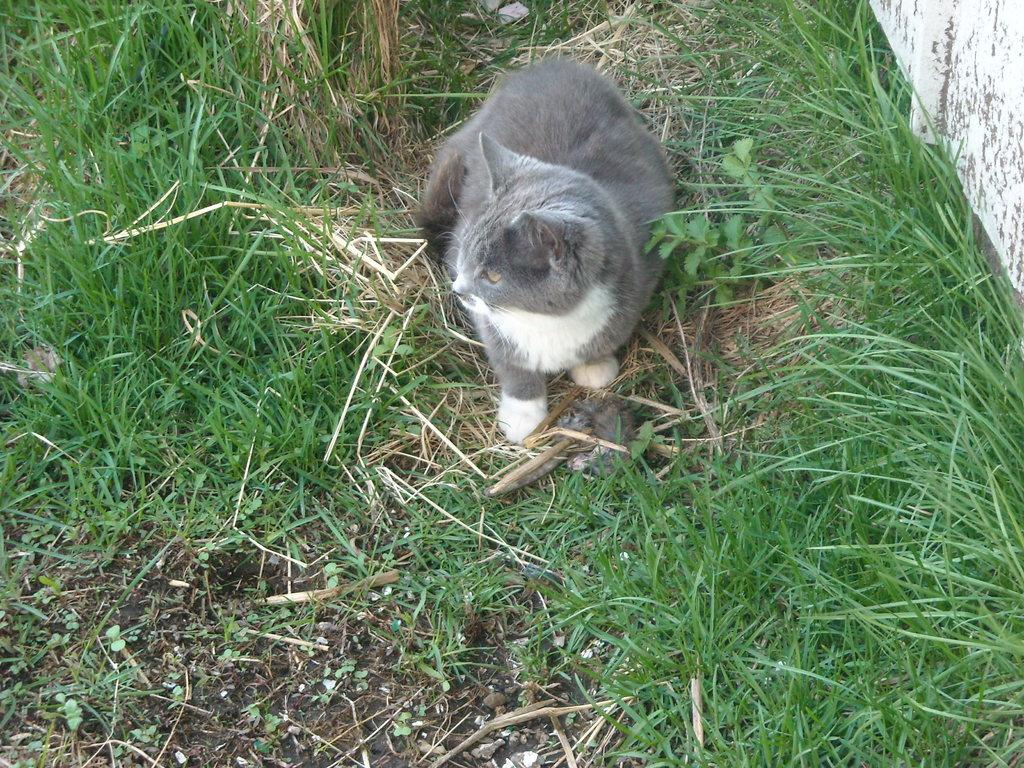What type of animal is on the ground in the image? There is a cat on the ground in the image. What type of vegetation is visible in the image? There is grass visible in the image. What is located on the right side of the image? There is a wall on the right side of the image. How many beams can be seen supporting the cat in the image? There are no beams visible in the image, and the cat is not being supported by any beams. 